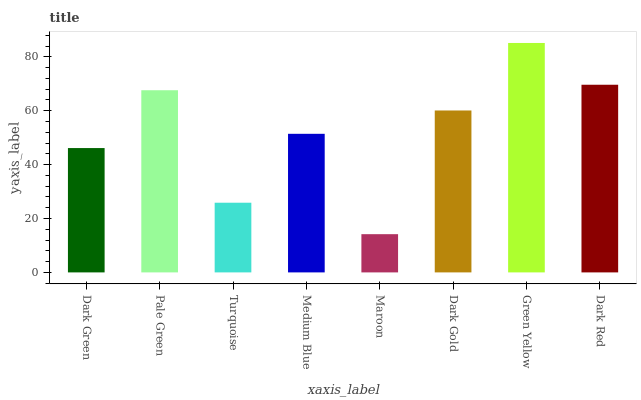Is Maroon the minimum?
Answer yes or no. Yes. Is Green Yellow the maximum?
Answer yes or no. Yes. Is Pale Green the minimum?
Answer yes or no. No. Is Pale Green the maximum?
Answer yes or no. No. Is Pale Green greater than Dark Green?
Answer yes or no. Yes. Is Dark Green less than Pale Green?
Answer yes or no. Yes. Is Dark Green greater than Pale Green?
Answer yes or no. No. Is Pale Green less than Dark Green?
Answer yes or no. No. Is Dark Gold the high median?
Answer yes or no. Yes. Is Medium Blue the low median?
Answer yes or no. Yes. Is Turquoise the high median?
Answer yes or no. No. Is Dark Gold the low median?
Answer yes or no. No. 